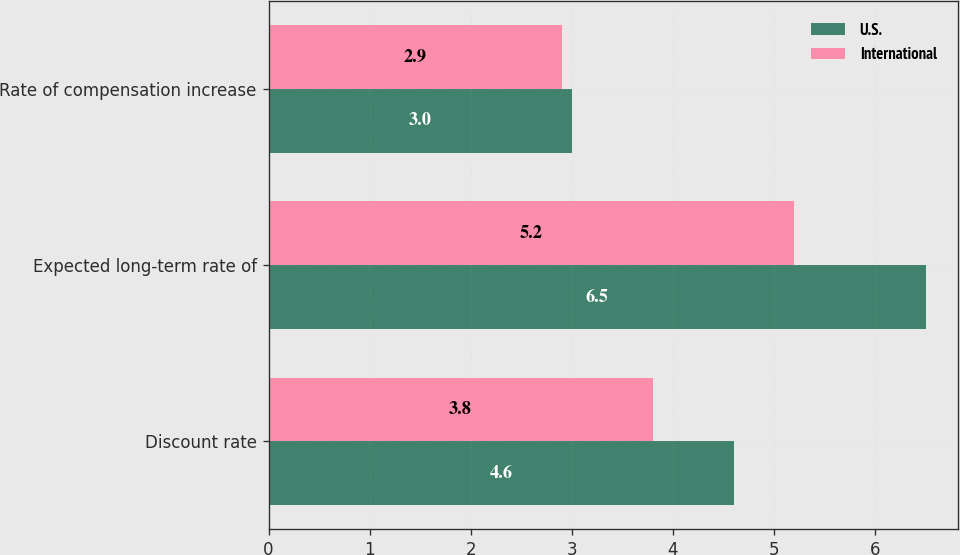Convert chart. <chart><loc_0><loc_0><loc_500><loc_500><stacked_bar_chart><ecel><fcel>Discount rate<fcel>Expected long-term rate of<fcel>Rate of compensation increase<nl><fcel>U.S.<fcel>4.6<fcel>6.5<fcel>3<nl><fcel>International<fcel>3.8<fcel>5.2<fcel>2.9<nl></chart> 